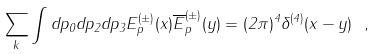<formula> <loc_0><loc_0><loc_500><loc_500>\sum _ { k } \int d p _ { 0 } d p _ { 2 } d p _ { 3 } { E } ^ { ( \pm ) } _ { p } ( x ) { \overline { E } } ^ { ( \pm ) } _ { p } ( y ) = ( 2 \pi ) ^ { 4 } \delta ^ { ( 4 ) } ( x - y ) \ ,</formula> 